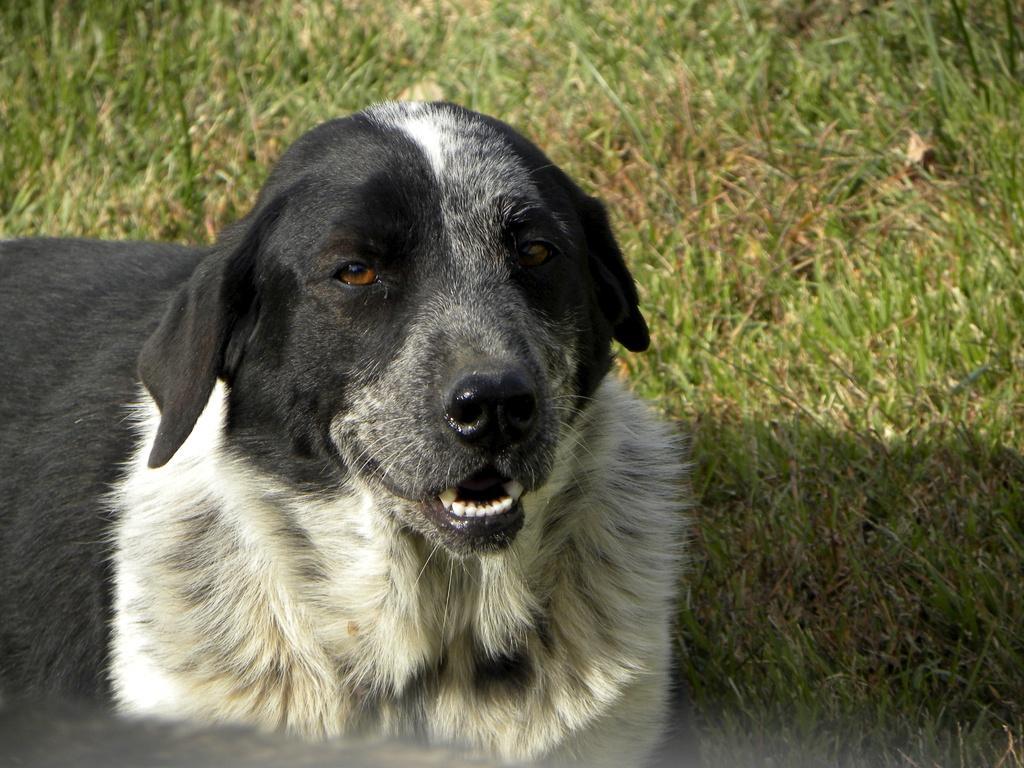How would you summarize this image in a sentence or two? In the image in the center, we can see the dog, which is in black and white color. In the background we can see the grass. 